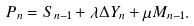Convert formula to latex. <formula><loc_0><loc_0><loc_500><loc_500>P _ { n } & = S _ { n - 1 } + \lambda \Delta Y _ { n } + \mu M _ { n - 1 } .</formula> 